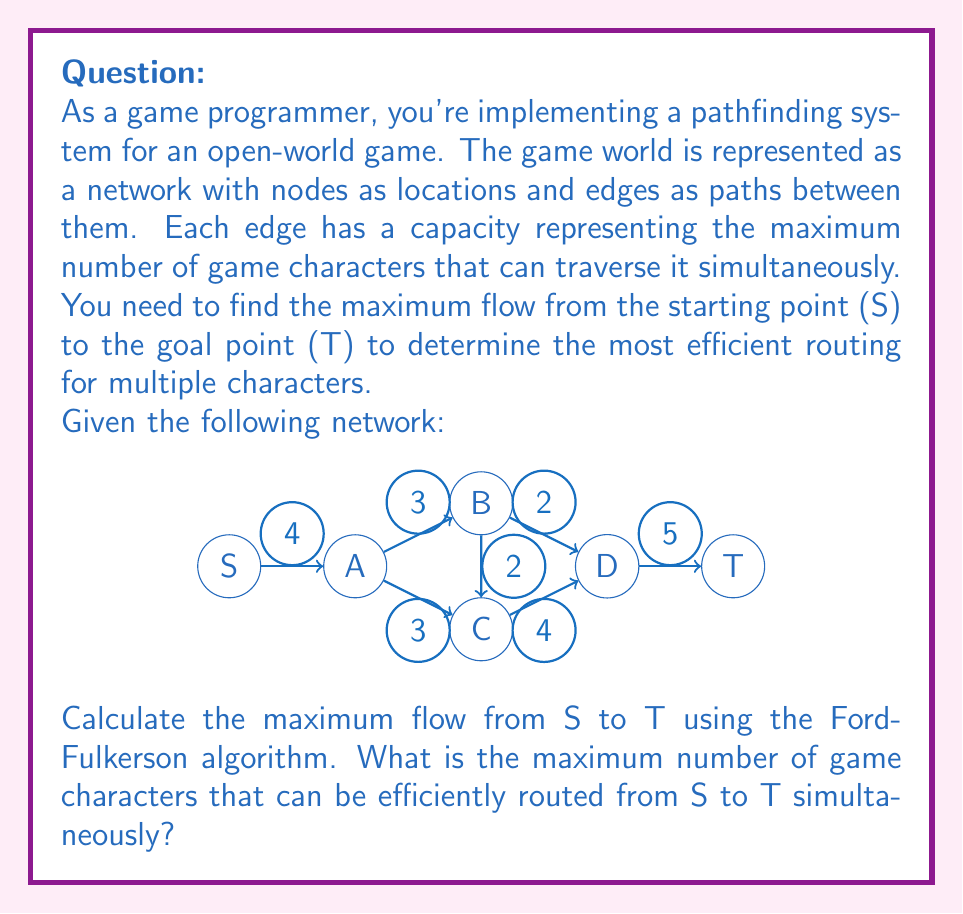Could you help me with this problem? To solve this problem, we'll use the Ford-Fulkerson algorithm:

1) Initialize flow on all edges to 0.

2) While there exists an augmenting path from S to T:
   a) Find an augmenting path
   b) Determine the bottleneck capacity
   c) Update the flow along the path

3) Repeat step 2 until no augmenting path exists

Let's go through the iterations:

Iteration 1:
Path: S -> A -> B -> D -> T
Bottleneck: min(4, 3, 2, 5) = 2
Flow becomes:
S -> A: 2/4
A -> B: 2/3
B -> D: 2/2
D -> T: 2/5

Iteration 2:
Path: S -> A -> C -> D -> T
Bottleneck: min(2, 3, 4, 3) = 2
Flow becomes:
S -> A: 4/4
A -> C: 2/3
C -> D: 2/4
D -> T: 4/5

Iteration 3:
Path: S -> A -> B -> C -> D -> T
Bottleneck: min(0, 1, 2, 2, 1) = 0

No more augmenting paths exist.

The maximum flow is the sum of flows into T, which is 4.
Answer: 4 